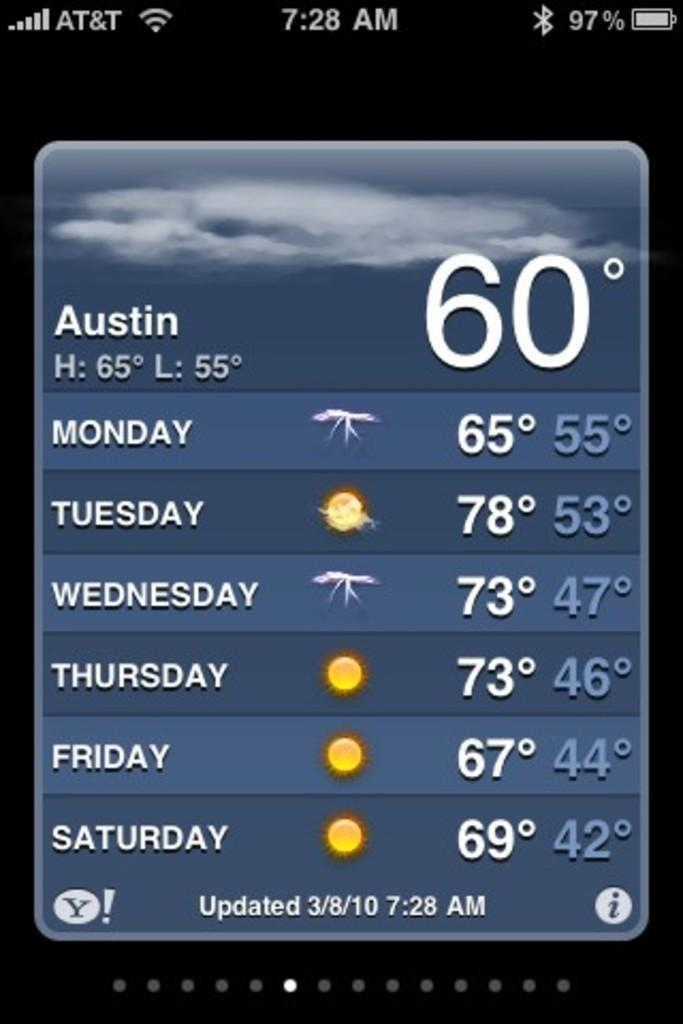<image>
Share a concise interpretation of the image provided. A phone showing the upcoming forecast for the week in Austin. 